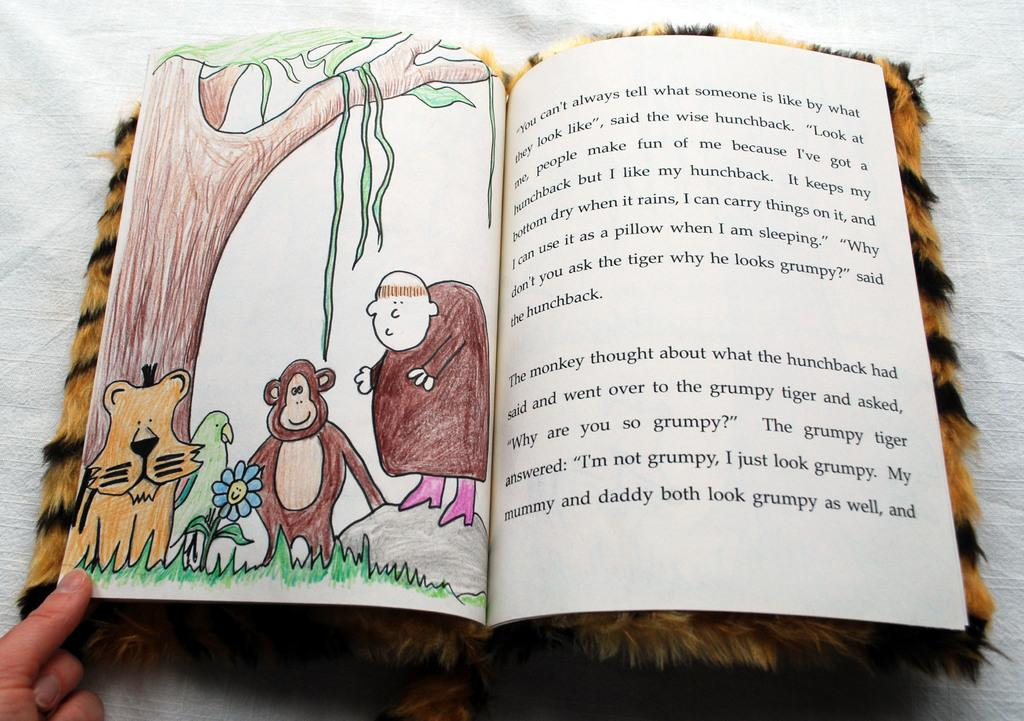<image>
Share a concise interpretation of the image provided. Book about the grumpy tiger who stayed looking grumpy and being mean to the monkey. 